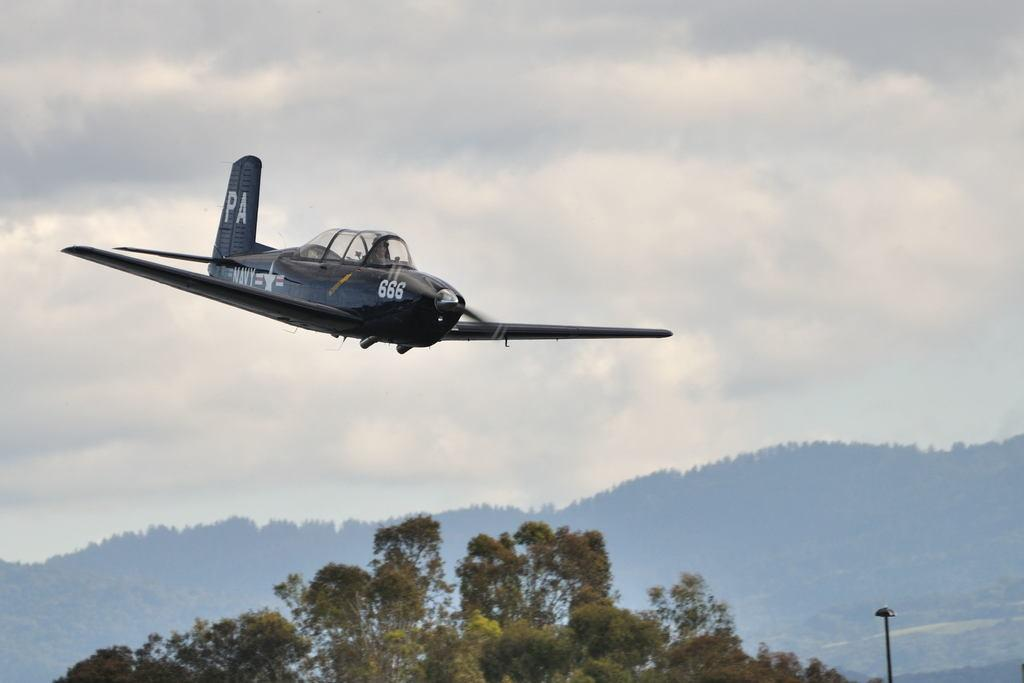<image>
Present a compact description of the photo's key features. a black airplane with 666 emblazoned near the front rotor. 